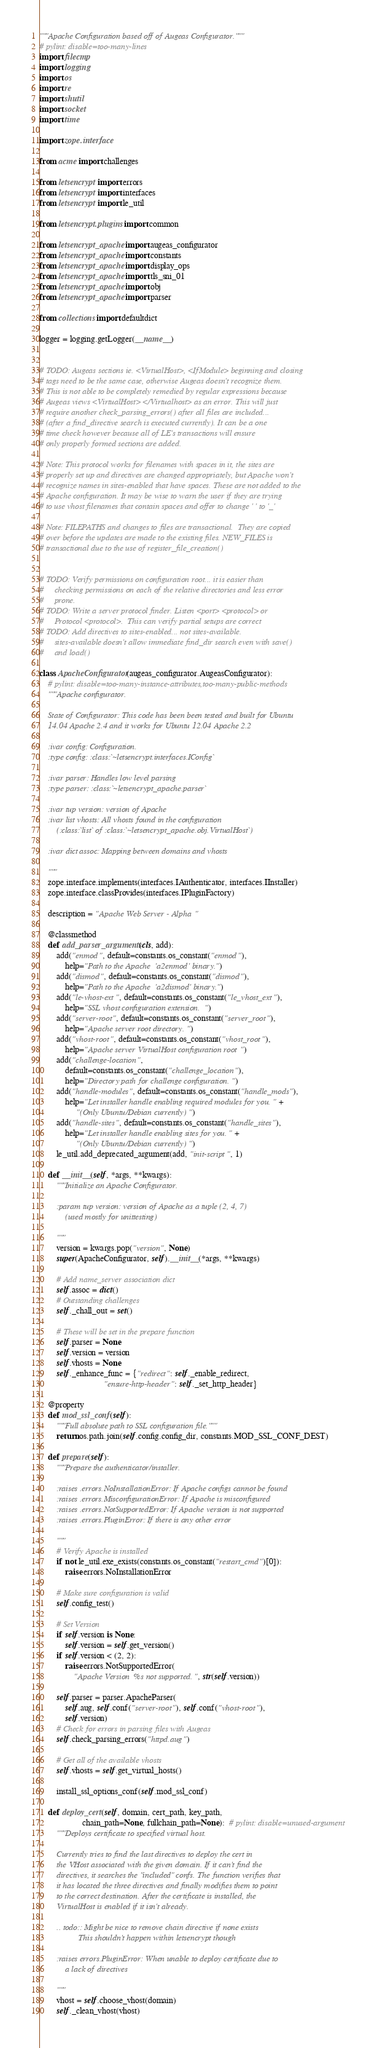<code> <loc_0><loc_0><loc_500><loc_500><_Python_>"""Apache Configuration based off of Augeas Configurator."""
# pylint: disable=too-many-lines
import filecmp
import logging
import os
import re
import shutil
import socket
import time

import zope.interface

from acme import challenges

from letsencrypt import errors
from letsencrypt import interfaces
from letsencrypt import le_util

from letsencrypt.plugins import common

from letsencrypt_apache import augeas_configurator
from letsencrypt_apache import constants
from letsencrypt_apache import display_ops
from letsencrypt_apache import tls_sni_01
from letsencrypt_apache import obj
from letsencrypt_apache import parser

from collections import defaultdict

logger = logging.getLogger(__name__)


# TODO: Augeas sections ie. <VirtualHost>, <IfModule> beginning and closing
# tags need to be the same case, otherwise Augeas doesn't recognize them.
# This is not able to be completely remedied by regular expressions because
# Augeas views <VirtualHost> </Virtualhost> as an error. This will just
# require another check_parsing_errors() after all files are included...
# (after a find_directive search is executed currently). It can be a one
# time check however because all of LE's transactions will ensure
# only properly formed sections are added.

# Note: This protocol works for filenames with spaces in it, the sites are
# properly set up and directives are changed appropriately, but Apache won't
# recognize names in sites-enabled that have spaces. These are not added to the
# Apache configuration. It may be wise to warn the user if they are trying
# to use vhost filenames that contain spaces and offer to change ' ' to '_'

# Note: FILEPATHS and changes to files are transactional.  They are copied
# over before the updates are made to the existing files. NEW_FILES is
# transactional due to the use of register_file_creation()


# TODO: Verify permissions on configuration root... it is easier than
#     checking permissions on each of the relative directories and less error
#     prone.
# TODO: Write a server protocol finder. Listen <port> <protocol> or
#     Protocol <protocol>.  This can verify partial setups are correct
# TODO: Add directives to sites-enabled... not sites-available.
#     sites-available doesn't allow immediate find_dir search even with save()
#     and load()

class ApacheConfigurator(augeas_configurator.AugeasConfigurator):
    # pylint: disable=too-many-instance-attributes,too-many-public-methods
    """Apache configurator.

    State of Configurator: This code has been been tested and built for Ubuntu
    14.04 Apache 2.4 and it works for Ubuntu 12.04 Apache 2.2

    :ivar config: Configuration.
    :type config: :class:`~letsencrypt.interfaces.IConfig`

    :ivar parser: Handles low level parsing
    :type parser: :class:`~letsencrypt_apache.parser`

    :ivar tup version: version of Apache
    :ivar list vhosts: All vhosts found in the configuration
        (:class:`list` of :class:`~letsencrypt_apache.obj.VirtualHost`)

    :ivar dict assoc: Mapping between domains and vhosts

    """
    zope.interface.implements(interfaces.IAuthenticator, interfaces.IInstaller)
    zope.interface.classProvides(interfaces.IPluginFactory)

    description = "Apache Web Server - Alpha"

    @classmethod
    def add_parser_arguments(cls, add):
        add("enmod", default=constants.os_constant("enmod"),
            help="Path to the Apache 'a2enmod' binary.")
        add("dismod", default=constants.os_constant("dismod"),
            help="Path to the Apache 'a2dismod' binary.")
        add("le-vhost-ext", default=constants.os_constant("le_vhost_ext"),
            help="SSL vhost configuration extension.")
        add("server-root", default=constants.os_constant("server_root"),
            help="Apache server root directory.")
        add("vhost-root", default=constants.os_constant("vhost_root"),
            help="Apache server VirtualHost configuration root")
        add("challenge-location",
            default=constants.os_constant("challenge_location"),
            help="Directory path for challenge configuration.")
        add("handle-modules", default=constants.os_constant("handle_mods"),
            help="Let installer handle enabling required modules for you." +
                 "(Only Ubuntu/Debian currently)")
        add("handle-sites", default=constants.os_constant("handle_sites"),
            help="Let installer handle enabling sites for you." +
                 "(Only Ubuntu/Debian currently)")
        le_util.add_deprecated_argument(add, "init-script", 1)

    def __init__(self, *args, **kwargs):
        """Initialize an Apache Configurator.

        :param tup version: version of Apache as a tuple (2, 4, 7)
            (used mostly for unittesting)

        """
        version = kwargs.pop("version", None)
        super(ApacheConfigurator, self).__init__(*args, **kwargs)

        # Add name_server association dict
        self.assoc = dict()
        # Outstanding challenges
        self._chall_out = set()

        # These will be set in the prepare function
        self.parser = None
        self.version = version
        self.vhosts = None
        self._enhance_func = {"redirect": self._enable_redirect,
                              "ensure-http-header": self._set_http_header}

    @property
    def mod_ssl_conf(self):
        """Full absolute path to SSL configuration file."""
        return os.path.join(self.config.config_dir, constants.MOD_SSL_CONF_DEST)

    def prepare(self):
        """Prepare the authenticator/installer.

        :raises .errors.NoInstallationError: If Apache configs cannot be found
        :raises .errors.MisconfigurationError: If Apache is misconfigured
        :raises .errors.NotSupportedError: If Apache version is not supported
        :raises .errors.PluginError: If there is any other error

        """
        # Verify Apache is installed
        if not le_util.exe_exists(constants.os_constant("restart_cmd")[0]):
            raise errors.NoInstallationError

        # Make sure configuration is valid
        self.config_test()

        # Set Version
        if self.version is None:
            self.version = self.get_version()
        if self.version < (2, 2):
            raise errors.NotSupportedError(
                "Apache Version %s not supported.", str(self.version))

        self.parser = parser.ApacheParser(
            self.aug, self.conf("server-root"), self.conf("vhost-root"),
            self.version)
        # Check for errors in parsing files with Augeas
        self.check_parsing_errors("httpd.aug")

        # Get all of the available vhosts
        self.vhosts = self.get_virtual_hosts()

        install_ssl_options_conf(self.mod_ssl_conf)

    def deploy_cert(self, domain, cert_path, key_path,
                    chain_path=None, fullchain_path=None):  # pylint: disable=unused-argument
        """Deploys certificate to specified virtual host.

        Currently tries to find the last directives to deploy the cert in
        the VHost associated with the given domain. If it can't find the
        directives, it searches the "included" confs. The function verifies that
        it has located the three directives and finally modifies them to point
        to the correct destination. After the certificate is installed, the
        VirtualHost is enabled if it isn't already.

        .. todo:: Might be nice to remove chain directive if none exists
                  This shouldn't happen within letsencrypt though

        :raises errors.PluginError: When unable to deploy certificate due to
            a lack of directives

        """
        vhost = self.choose_vhost(domain)
        self._clean_vhost(vhost)
</code> 